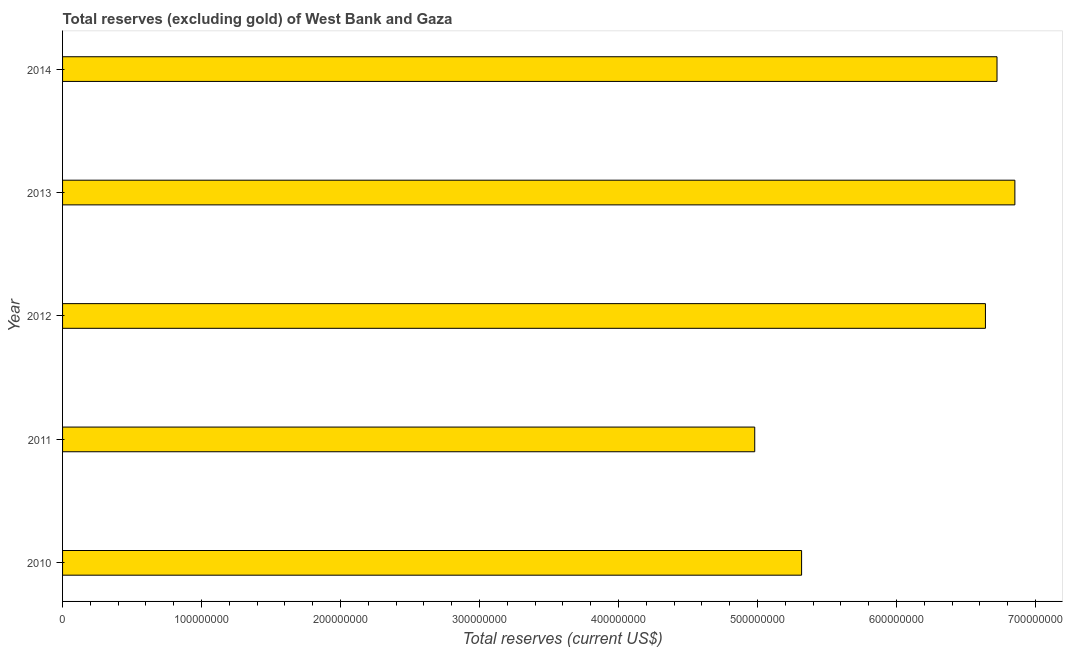What is the title of the graph?
Your answer should be very brief. Total reserves (excluding gold) of West Bank and Gaza. What is the label or title of the X-axis?
Provide a succinct answer. Total reserves (current US$). What is the total reserves (excluding gold) in 2014?
Your answer should be compact. 6.72e+08. Across all years, what is the maximum total reserves (excluding gold)?
Offer a terse response. 6.85e+08. Across all years, what is the minimum total reserves (excluding gold)?
Ensure brevity in your answer.  4.98e+08. In which year was the total reserves (excluding gold) maximum?
Provide a short and direct response. 2013. In which year was the total reserves (excluding gold) minimum?
Keep it short and to the point. 2011. What is the sum of the total reserves (excluding gold)?
Offer a terse response. 3.05e+09. What is the difference between the total reserves (excluding gold) in 2013 and 2014?
Give a very brief answer. 1.28e+07. What is the average total reserves (excluding gold) per year?
Your answer should be compact. 6.10e+08. What is the median total reserves (excluding gold)?
Your answer should be compact. 6.64e+08. Do a majority of the years between 2011 and 2013 (inclusive) have total reserves (excluding gold) greater than 360000000 US$?
Offer a very short reply. Yes. What is the ratio of the total reserves (excluding gold) in 2010 to that in 2012?
Provide a succinct answer. 0.8. Is the total reserves (excluding gold) in 2011 less than that in 2012?
Provide a succinct answer. Yes. What is the difference between the highest and the second highest total reserves (excluding gold)?
Provide a short and direct response. 1.28e+07. Is the sum of the total reserves (excluding gold) in 2010 and 2013 greater than the maximum total reserves (excluding gold) across all years?
Your answer should be very brief. Yes. What is the difference between the highest and the lowest total reserves (excluding gold)?
Your answer should be compact. 1.87e+08. In how many years, is the total reserves (excluding gold) greater than the average total reserves (excluding gold) taken over all years?
Offer a terse response. 3. How many bars are there?
Your response must be concise. 5. Are all the bars in the graph horizontal?
Keep it short and to the point. Yes. How many years are there in the graph?
Make the answer very short. 5. What is the difference between two consecutive major ticks on the X-axis?
Your answer should be very brief. 1.00e+08. What is the Total reserves (current US$) of 2010?
Offer a very short reply. 5.32e+08. What is the Total reserves (current US$) in 2011?
Offer a terse response. 4.98e+08. What is the Total reserves (current US$) in 2012?
Provide a succinct answer. 6.64e+08. What is the Total reserves (current US$) of 2013?
Keep it short and to the point. 6.85e+08. What is the Total reserves (current US$) in 2014?
Provide a succinct answer. 6.72e+08. What is the difference between the Total reserves (current US$) in 2010 and 2011?
Make the answer very short. 3.37e+07. What is the difference between the Total reserves (current US$) in 2010 and 2012?
Provide a succinct answer. -1.32e+08. What is the difference between the Total reserves (current US$) in 2010 and 2013?
Ensure brevity in your answer.  -1.53e+08. What is the difference between the Total reserves (current US$) in 2010 and 2014?
Offer a very short reply. -1.41e+08. What is the difference between the Total reserves (current US$) in 2011 and 2012?
Your answer should be compact. -1.66e+08. What is the difference between the Total reserves (current US$) in 2011 and 2013?
Ensure brevity in your answer.  -1.87e+08. What is the difference between the Total reserves (current US$) in 2011 and 2014?
Offer a very short reply. -1.74e+08. What is the difference between the Total reserves (current US$) in 2012 and 2013?
Offer a terse response. -2.12e+07. What is the difference between the Total reserves (current US$) in 2012 and 2014?
Provide a short and direct response. -8.34e+06. What is the difference between the Total reserves (current US$) in 2013 and 2014?
Keep it short and to the point. 1.28e+07. What is the ratio of the Total reserves (current US$) in 2010 to that in 2011?
Make the answer very short. 1.07. What is the ratio of the Total reserves (current US$) in 2010 to that in 2012?
Make the answer very short. 0.8. What is the ratio of the Total reserves (current US$) in 2010 to that in 2013?
Ensure brevity in your answer.  0.78. What is the ratio of the Total reserves (current US$) in 2010 to that in 2014?
Make the answer very short. 0.79. What is the ratio of the Total reserves (current US$) in 2011 to that in 2013?
Ensure brevity in your answer.  0.73. What is the ratio of the Total reserves (current US$) in 2011 to that in 2014?
Give a very brief answer. 0.74. What is the ratio of the Total reserves (current US$) in 2012 to that in 2013?
Your answer should be compact. 0.97. 